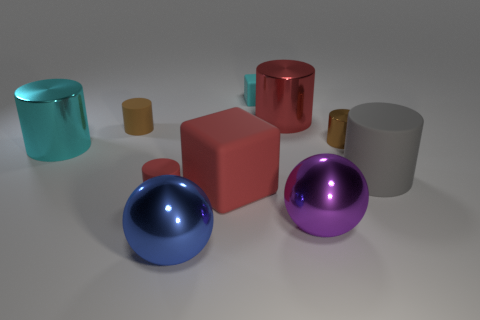Subtract all cyan cylinders. How many cylinders are left? 5 Subtract all big red metal cylinders. How many cylinders are left? 5 Subtract all purple cylinders. Subtract all gray cubes. How many cylinders are left? 6 Subtract all cylinders. How many objects are left? 4 Add 7 big red metal spheres. How many big red metal spheres exist? 7 Subtract 0 red spheres. How many objects are left? 10 Subtract all small cylinders. Subtract all large metal cylinders. How many objects are left? 5 Add 2 small brown shiny things. How many small brown shiny things are left? 3 